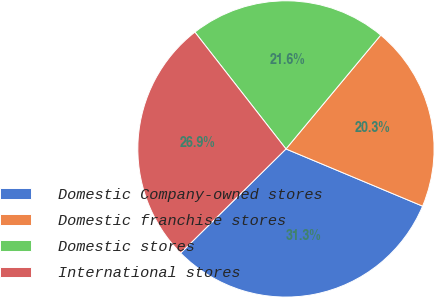<chart> <loc_0><loc_0><loc_500><loc_500><pie_chart><fcel>Domestic Company-owned stores<fcel>Domestic franchise stores<fcel>Domestic stores<fcel>International stores<nl><fcel>31.28%<fcel>20.26%<fcel>21.59%<fcel>26.87%<nl></chart> 